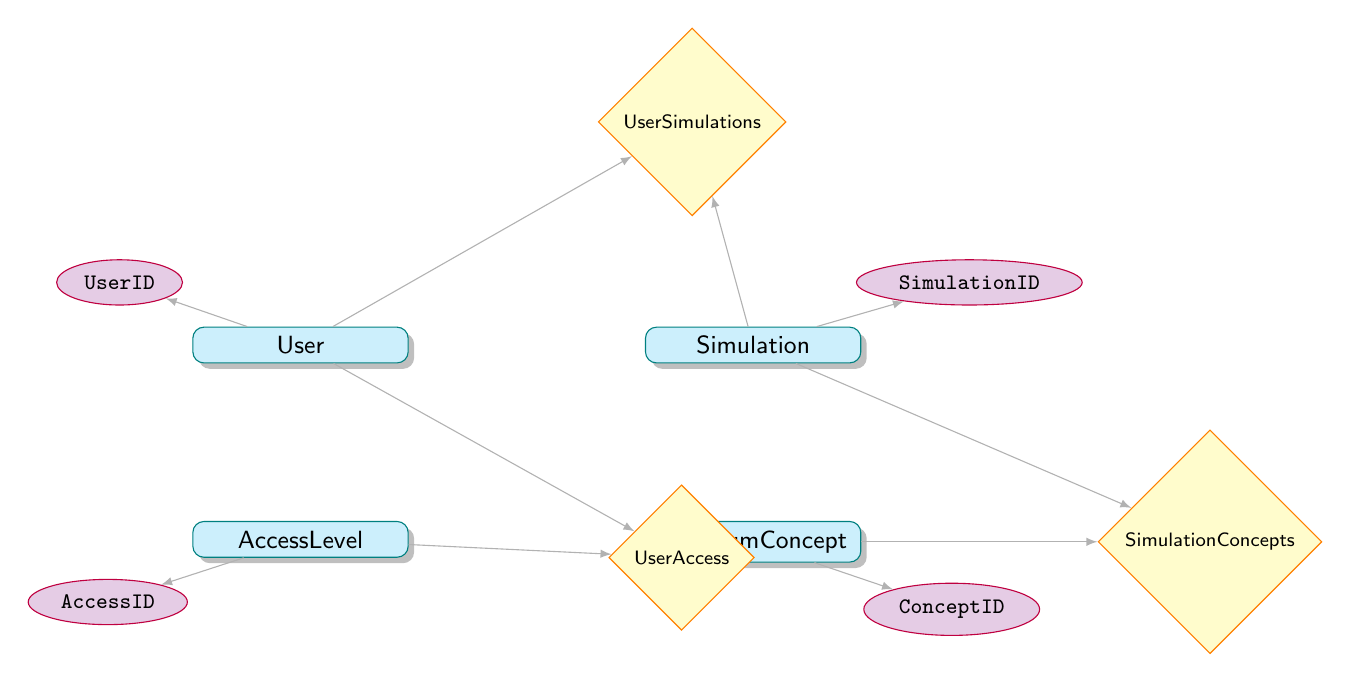What is the primary key of the User entity? The primary key is explicitly indicated in the diagram for each entity. For the User entity, the primary key is labeled as "UserID."
Answer: UserID How many attributes does the Simulation entity have? To find the number of attributes for the Simulation entity, count the listed items under its attributes section. The Simulation entity has four attributes: SimulationID, Title, Description, and DateCreated.
Answer: 4 What relationship connects the User and AccessLevel entities? The relationship between User and AccessLevel is shown by the UserAccess relationship, which connects these two entities.
Answer: UserAccess Which entity is related to both Simulation and QuantumConcept? The relationship SimulationConcepts connects both the Simulation and QuantumConcept entities together, indicating they relate to one another through this relationship.
Answer: SimulationConcepts What is the primary key of the QuantumConcept entity? Similar to other entities, the primary key for the QuantumConcept entity is identified in the diagram. It is labeled as "ConceptID."
Answer: ConceptID How many relationships are present in the diagram? Count the number of relationships depicted in the diagram. There are three relationships: UserSimulations, UserAccess, and SimulationConcepts.
Answer: 3 What attribute is common between the User and UserSimulations entities? The UserID attribute serves as the common element linking the User entity to the UserSimulations relationship. This attribute is used for identifying users in their simulation progress.
Answer: UserID Which two entities are connected through more than one relationship? The User and Simulation entities are connected through the UserSimulations relationship, and User accesses via the UserAccess relationship, making it the only pair with multiple connections.
Answer: User and Simulation What type of diagram is this? This diagram illustrates the structure and relationships of a User Management System specifically aligned with a mobile app focused on quantum physics, prominently utilizing entity-relationship modeling.
Answer: Entity Relationship Diagram 